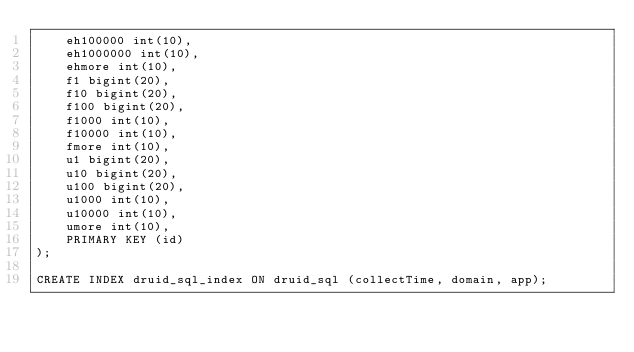<code> <loc_0><loc_0><loc_500><loc_500><_SQL_>	eh100000 int(10), 
	eh1000000 int(10), 
	ehmore int(10), 
	f1 bigint(20), 
	f10 bigint(20), 
	f100 bigint(20), 
	f1000 int(10), 
	f10000 int(10), 
	fmore int(10), 
	u1 bigint(20), 
	u10 bigint(20), 
	u100 bigint(20), 
	u1000 int(10), 
	u10000 int(10), 
	umore int(10), 
	PRIMARY KEY (id)
);

CREATE INDEX druid_sql_index ON druid_sql (collectTime, domain, app);</code> 